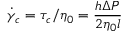<formula> <loc_0><loc_0><loc_500><loc_500>\dot { \gamma } _ { c } = \tau _ { c } / \eta _ { 0 } = \frac { h \Delta P } { 2 \eta _ { 0 } l }</formula> 